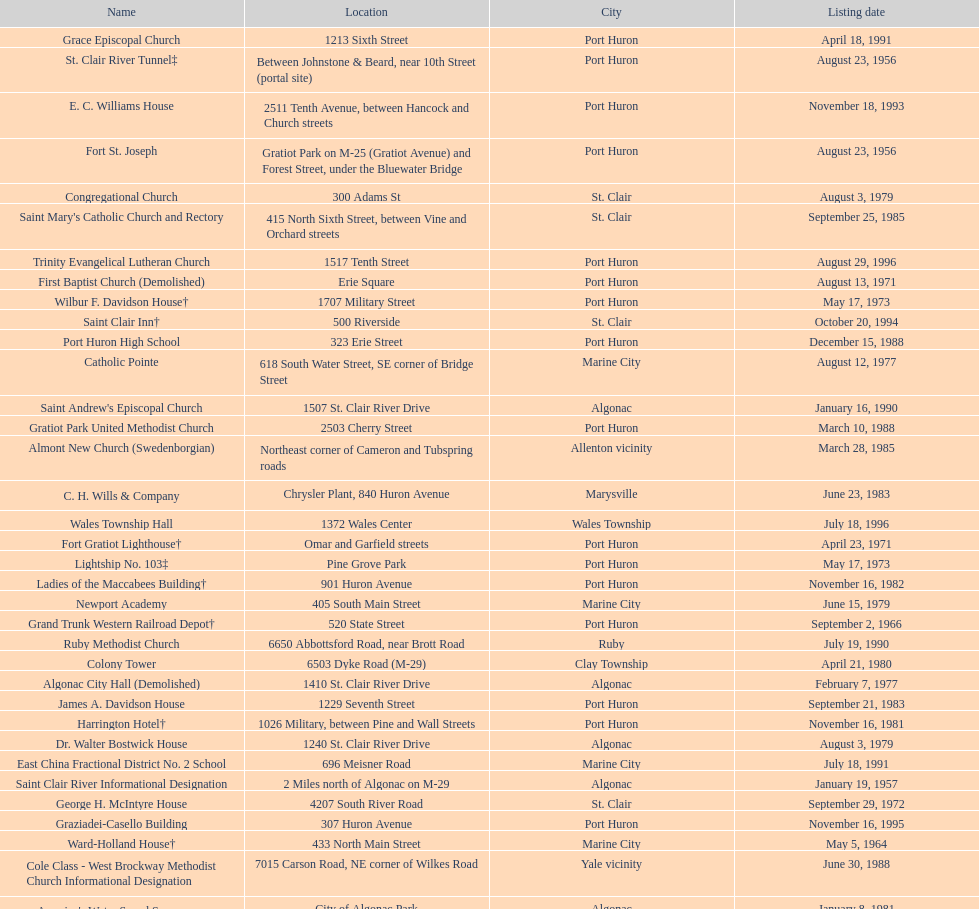What is the number of properties on the list that have been demolished? 2. 